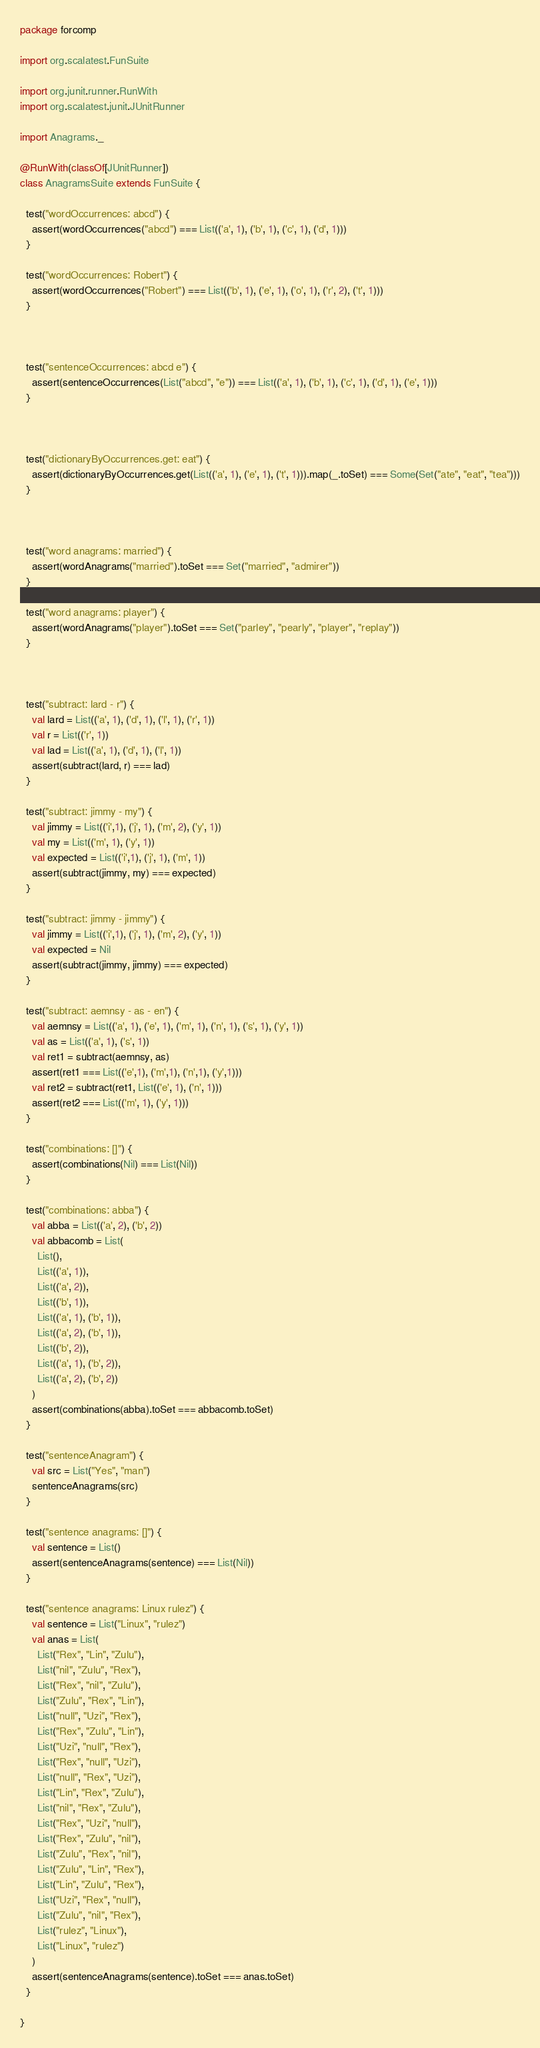Convert code to text. <code><loc_0><loc_0><loc_500><loc_500><_Scala_>package forcomp

import org.scalatest.FunSuite

import org.junit.runner.RunWith
import org.scalatest.junit.JUnitRunner

import Anagrams._

@RunWith(classOf[JUnitRunner])
class AnagramsSuite extends FunSuite {

  test("wordOccurrences: abcd") {
    assert(wordOccurrences("abcd") === List(('a', 1), ('b', 1), ('c', 1), ('d', 1)))
  }

  test("wordOccurrences: Robert") {
    assert(wordOccurrences("Robert") === List(('b', 1), ('e', 1), ('o', 1), ('r', 2), ('t', 1)))
  }



  test("sentenceOccurrences: abcd e") {
    assert(sentenceOccurrences(List("abcd", "e")) === List(('a', 1), ('b', 1), ('c', 1), ('d', 1), ('e', 1)))
  }



  test("dictionaryByOccurrences.get: eat") {
    assert(dictionaryByOccurrences.get(List(('a', 1), ('e', 1), ('t', 1))).map(_.toSet) === Some(Set("ate", "eat", "tea")))
  }



  test("word anagrams: married") {
    assert(wordAnagrams("married").toSet === Set("married", "admirer"))
  }

  test("word anagrams: player") {
    assert(wordAnagrams("player").toSet === Set("parley", "pearly", "player", "replay"))
  }



  test("subtract: lard - r") {
    val lard = List(('a', 1), ('d', 1), ('l', 1), ('r', 1))
    val r = List(('r', 1))
    val lad = List(('a', 1), ('d', 1), ('l', 1))
    assert(subtract(lard, r) === lad)
  }

  test("subtract: jimmy - my") {
    val jimmy = List(('i',1), ('j', 1), ('m', 2), ('y', 1))
    val my = List(('m', 1), ('y', 1))
    val expected = List(('i',1), ('j', 1), ('m', 1))
    assert(subtract(jimmy, my) === expected)
  }

  test("subtract: jimmy - jimmy") {
    val jimmy = List(('i',1), ('j', 1), ('m', 2), ('y', 1))
    val expected = Nil
    assert(subtract(jimmy, jimmy) === expected)
  }

  test("subtract: aemnsy - as - en") {
    val aemnsy = List(('a', 1), ('e', 1), ('m', 1), ('n', 1), ('s', 1), ('y', 1))
    val as = List(('a', 1), ('s', 1))
    val ret1 = subtract(aemnsy, as)
    assert(ret1 === List(('e',1), ('m',1), ('n',1), ('y',1)))
    val ret2 = subtract(ret1, List(('e', 1), ('n', 1)))
    assert(ret2 === List(('m', 1), ('y', 1)))
  }

  test("combinations: []") {
    assert(combinations(Nil) === List(Nil))
  }

  test("combinations: abba") {
    val abba = List(('a', 2), ('b', 2))
    val abbacomb = List(
      List(),
      List(('a', 1)),
      List(('a', 2)),
      List(('b', 1)),
      List(('a', 1), ('b', 1)),
      List(('a', 2), ('b', 1)),
      List(('b', 2)),
      List(('a', 1), ('b', 2)),
      List(('a', 2), ('b', 2))
    )
    assert(combinations(abba).toSet === abbacomb.toSet)
  }

  test("sentenceAnagram") {
    val src = List("Yes", "man")
    sentenceAnagrams(src)
  }

  test("sentence anagrams: []") {
    val sentence = List()
    assert(sentenceAnagrams(sentence) === List(Nil))
  }

  test("sentence anagrams: Linux rulez") {
    val sentence = List("Linux", "rulez")
    val anas = List(
      List("Rex", "Lin", "Zulu"),
      List("nil", "Zulu", "Rex"),
      List("Rex", "nil", "Zulu"),
      List("Zulu", "Rex", "Lin"),
      List("null", "Uzi", "Rex"),
      List("Rex", "Zulu", "Lin"),
      List("Uzi", "null", "Rex"),
      List("Rex", "null", "Uzi"),
      List("null", "Rex", "Uzi"),
      List("Lin", "Rex", "Zulu"),
      List("nil", "Rex", "Zulu"),
      List("Rex", "Uzi", "null"),
      List("Rex", "Zulu", "nil"),
      List("Zulu", "Rex", "nil"),
      List("Zulu", "Lin", "Rex"),
      List("Lin", "Zulu", "Rex"),
      List("Uzi", "Rex", "null"),
      List("Zulu", "nil", "Rex"),
      List("rulez", "Linux"),
      List("Linux", "rulez")
    )
    assert(sentenceAnagrams(sentence).toSet === anas.toSet)
  }  

}
</code> 